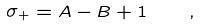<formula> <loc_0><loc_0><loc_500><loc_500>\sigma _ { + } = A - B + 1 \quad ,</formula> 